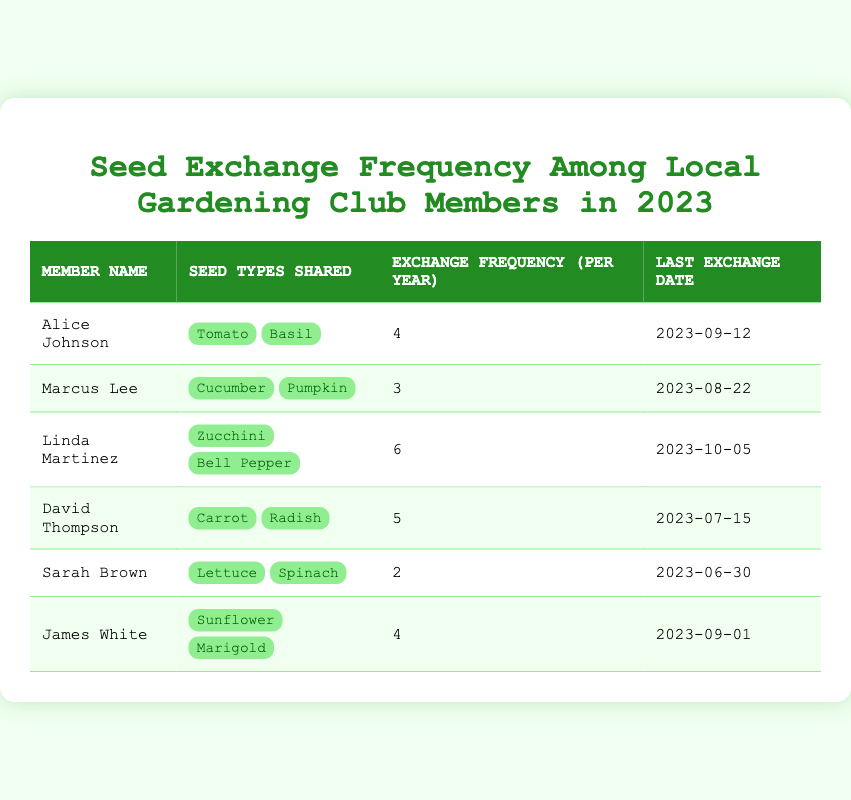What is the member name who shared the most types of seeds? The table shows the types of seeds shared by each member. Linda Martinez is listed with two types, which is the maximum compared to the others.
Answer: Linda Martinez How many seed types did Sarah Brown share? Looking at the table, Sarah Brown shared two types of seeds: Lettuce and Spinach.
Answer: 2 Who exchanged seeds last on September 12, 2023? Referring to the last exchange date column, Alice Johnson has the last exchange date of September 12, 2023.
Answer: Alice Johnson What is the total frequency of exchanges for all members? To find the total exchange frequency, we sum the exchange frequencies for each member: 4 + 3 + 6 + 5 + 2 + 4 = 24.
Answer: 24 Is James White's exchange frequency higher than David Thompson's? Comparing the two values in the table, James White has an exchange frequency of 4 while David Thompson has 5, meaning James White's frequency is not higher.
Answer: No What is the average exchange frequency among all members? We first calculate the total frequency as 24 from the previous question, then divide by the number of members (6): 24/6 = 4.
Answer: 4 Which member exchanged seeds the least often, and how often did they exchange? By examining the exchange frequency column for the smallest value, Sarah Brown has the least frequency of 2 exchanges per year.
Answer: Sarah Brown, 2 What is the last exchange date for members who shared Zucchini? The table indicates that Linda Martinez shared Zucchini and her last exchange date was October 5, 2023.
Answer: October 5, 2023 Are any members sharing the same types of seeds? Looking closely, each member in the table shares unique types of seeds, indicating that no members share the same types of seeds this year.
Answer: No 